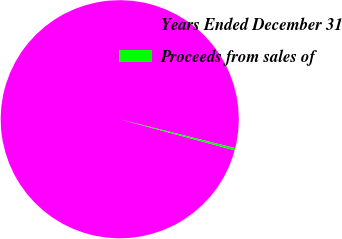<chart> <loc_0><loc_0><loc_500><loc_500><pie_chart><fcel>Years Ended December 31<fcel>Proceeds from sales of<nl><fcel>99.7%<fcel>0.3%<nl></chart> 